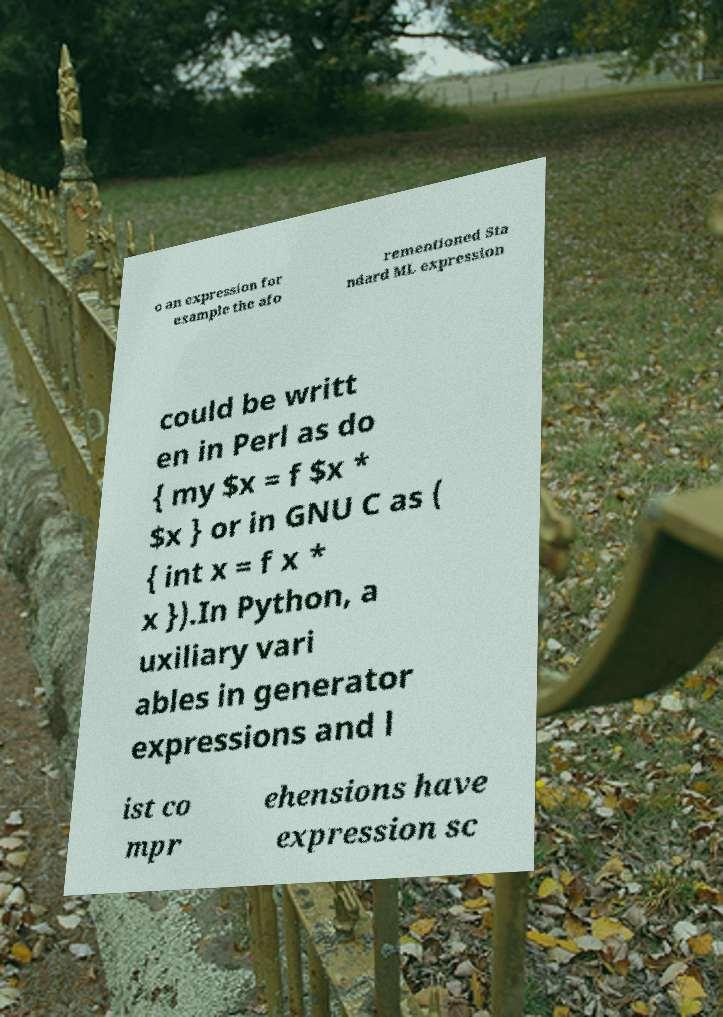What messages or text are displayed in this image? I need them in a readable, typed format. o an expression for example the afo rementioned Sta ndard ML expression could be writt en in Perl as do { my $x = f $x * $x } or in GNU C as ( { int x = f x * x }).In Python, a uxiliary vari ables in generator expressions and l ist co mpr ehensions have expression sc 